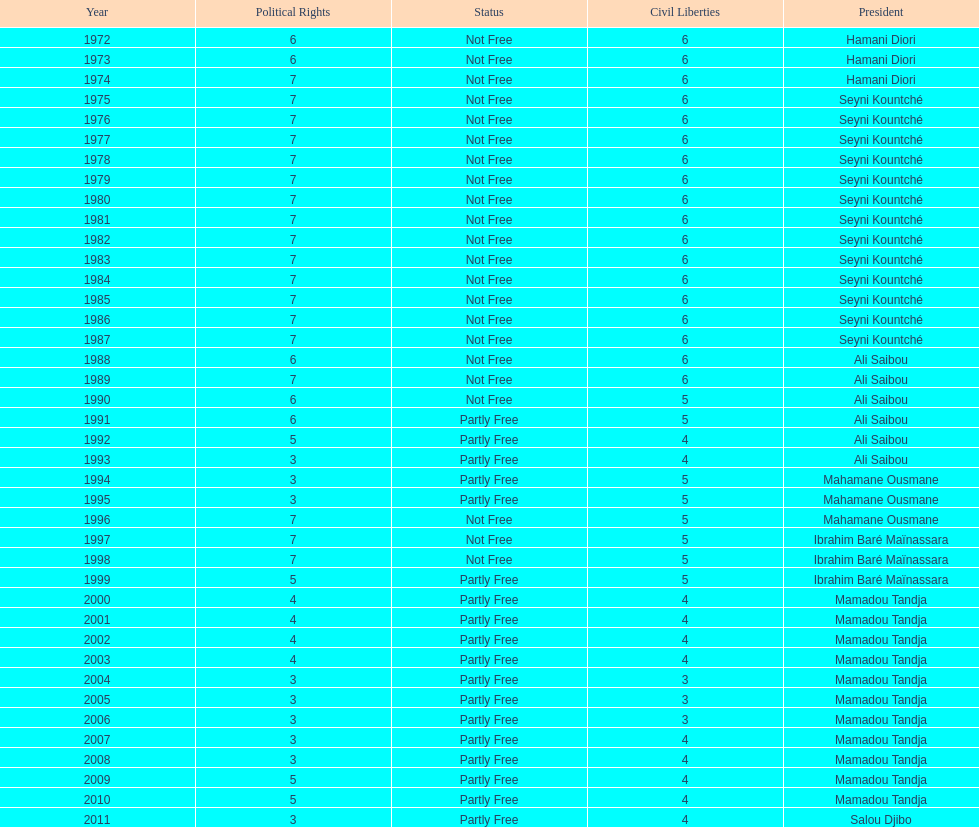How long did it take for civil liberties to decrease below 6? 18 years. 